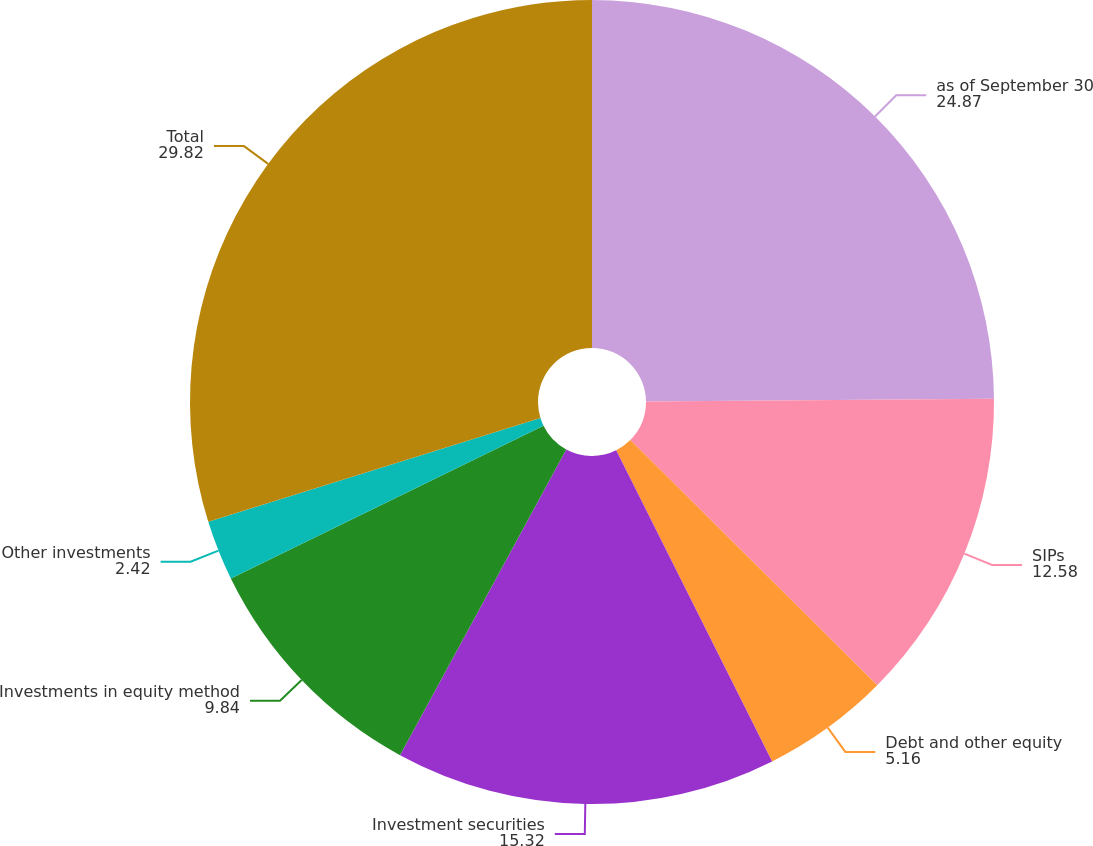<chart> <loc_0><loc_0><loc_500><loc_500><pie_chart><fcel>as of September 30<fcel>SIPs<fcel>Debt and other equity<fcel>Investment securities<fcel>Investments in equity method<fcel>Other investments<fcel>Total<nl><fcel>24.87%<fcel>12.58%<fcel>5.16%<fcel>15.32%<fcel>9.84%<fcel>2.42%<fcel>29.82%<nl></chart> 